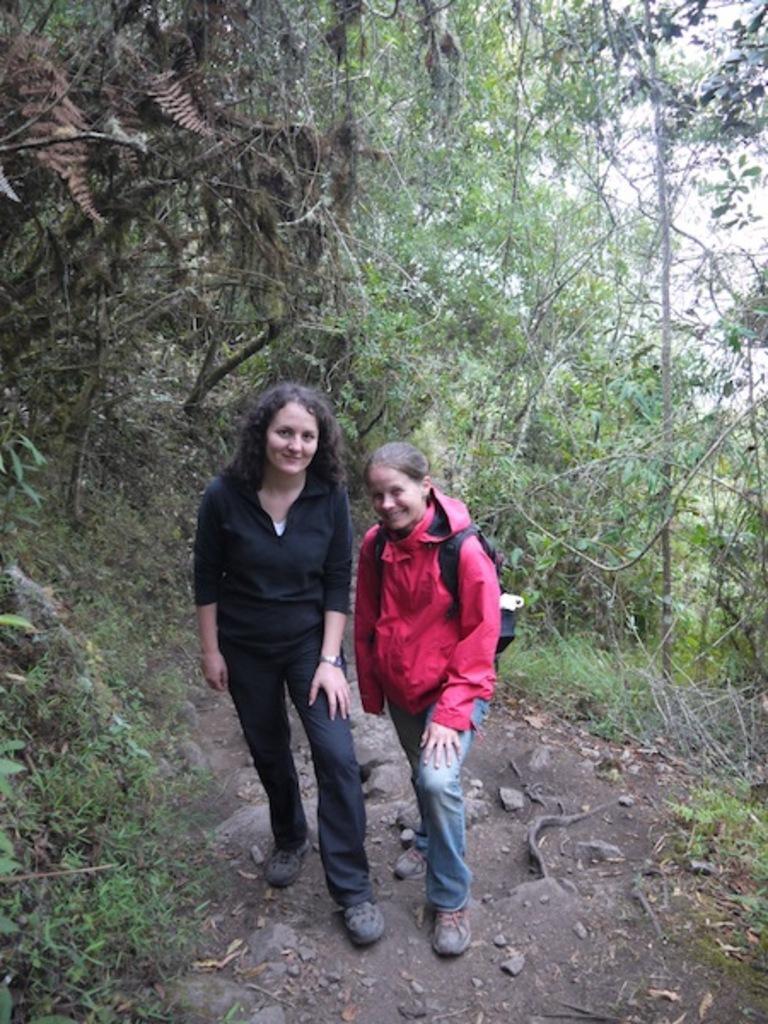Could you give a brief overview of what you see in this image? In this image I can see two people are standing and wearing pink, black and blue color dresses. I can see few trees and the sky. 